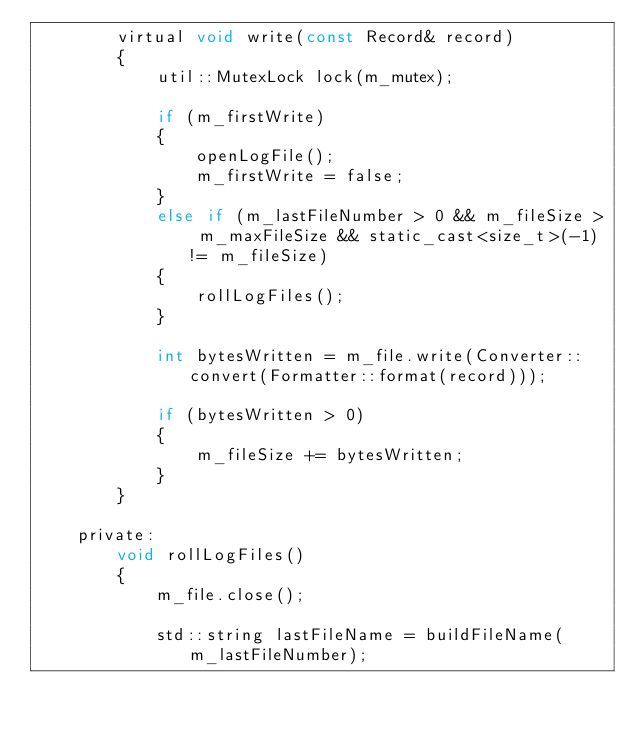Convert code to text. <code><loc_0><loc_0><loc_500><loc_500><_C_>        virtual void write(const Record& record)
        {
            util::MutexLock lock(m_mutex);

            if (m_firstWrite)
            {
                openLogFile();
                m_firstWrite = false;
            }
            else if (m_lastFileNumber > 0 && m_fileSize > m_maxFileSize && static_cast<size_t>(-1) != m_fileSize)
            {
                rollLogFiles();
            }

            int bytesWritten = m_file.write(Converter::convert(Formatter::format(record)));

            if (bytesWritten > 0)
            {
                m_fileSize += bytesWritten;
            }
        }

    private:
        void rollLogFiles()
        {
            m_file.close();

            std::string lastFileName = buildFileName(m_lastFileNumber);</code> 